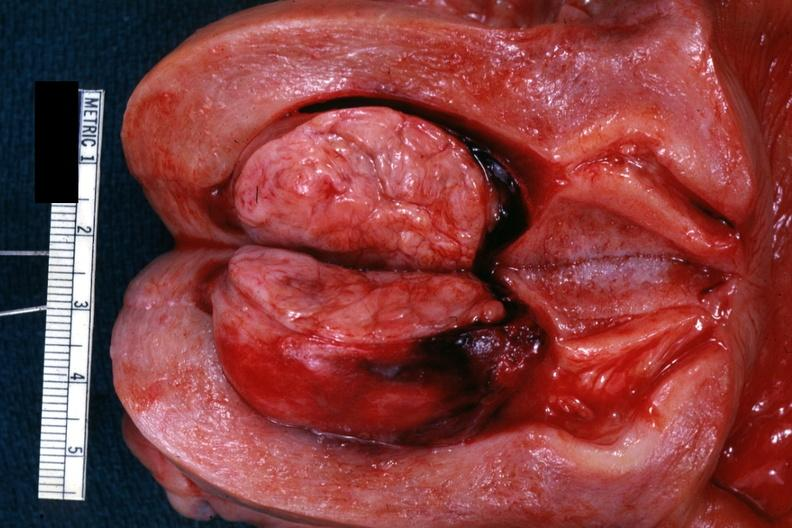s left ventricle hypertrophy present?
Answer the question using a single word or phrase. No 